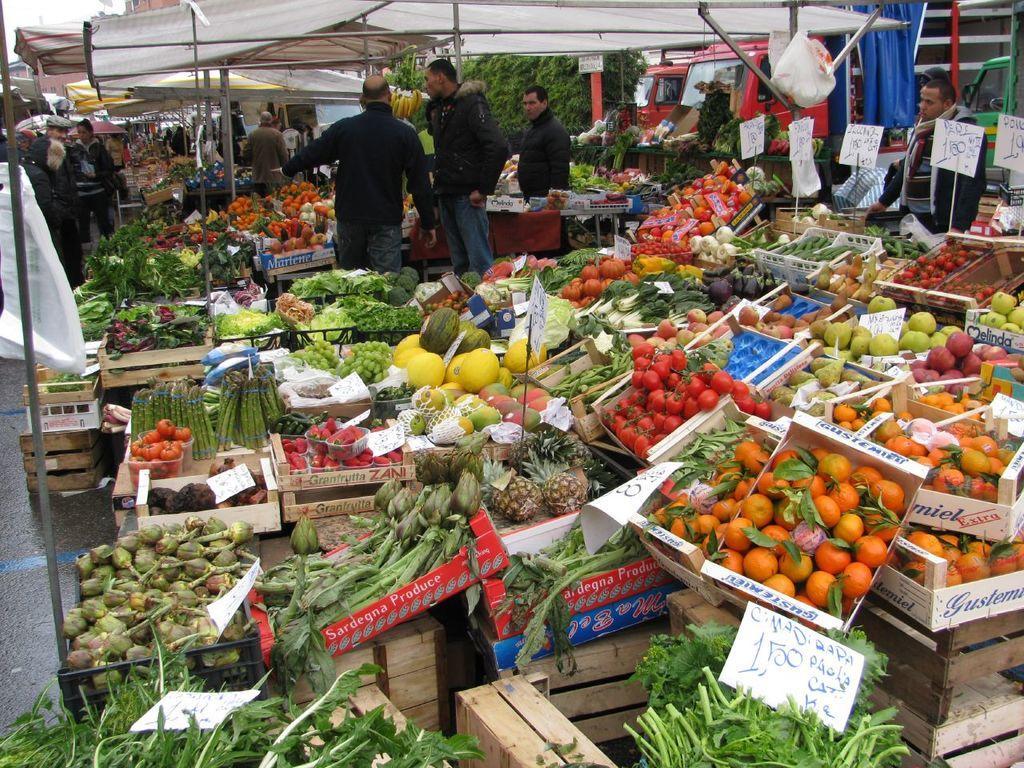In one or two sentences, can you explain what this image depicts? In this picture we can see there are vegetables in the trays and baskets. Behind the vegetables, there a price boards, stalls and there are groups of people. Behind the stalls, there are buildings and trees. At the top right corner of the image, there are vehicles. On the left side of the image, there is a pole. 